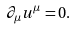Convert formula to latex. <formula><loc_0><loc_0><loc_500><loc_500>\partial _ { \mu } u ^ { \mu } = 0 .</formula> 